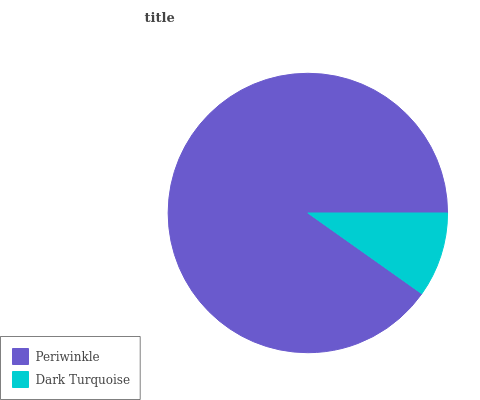Is Dark Turquoise the minimum?
Answer yes or no. Yes. Is Periwinkle the maximum?
Answer yes or no. Yes. Is Dark Turquoise the maximum?
Answer yes or no. No. Is Periwinkle greater than Dark Turquoise?
Answer yes or no. Yes. Is Dark Turquoise less than Periwinkle?
Answer yes or no. Yes. Is Dark Turquoise greater than Periwinkle?
Answer yes or no. No. Is Periwinkle less than Dark Turquoise?
Answer yes or no. No. Is Periwinkle the high median?
Answer yes or no. Yes. Is Dark Turquoise the low median?
Answer yes or no. Yes. Is Dark Turquoise the high median?
Answer yes or no. No. Is Periwinkle the low median?
Answer yes or no. No. 